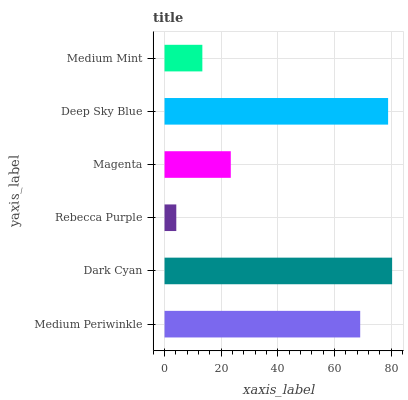Is Rebecca Purple the minimum?
Answer yes or no. Yes. Is Dark Cyan the maximum?
Answer yes or no. Yes. Is Dark Cyan the minimum?
Answer yes or no. No. Is Rebecca Purple the maximum?
Answer yes or no. No. Is Dark Cyan greater than Rebecca Purple?
Answer yes or no. Yes. Is Rebecca Purple less than Dark Cyan?
Answer yes or no. Yes. Is Rebecca Purple greater than Dark Cyan?
Answer yes or no. No. Is Dark Cyan less than Rebecca Purple?
Answer yes or no. No. Is Medium Periwinkle the high median?
Answer yes or no. Yes. Is Magenta the low median?
Answer yes or no. Yes. Is Dark Cyan the high median?
Answer yes or no. No. Is Medium Periwinkle the low median?
Answer yes or no. No. 